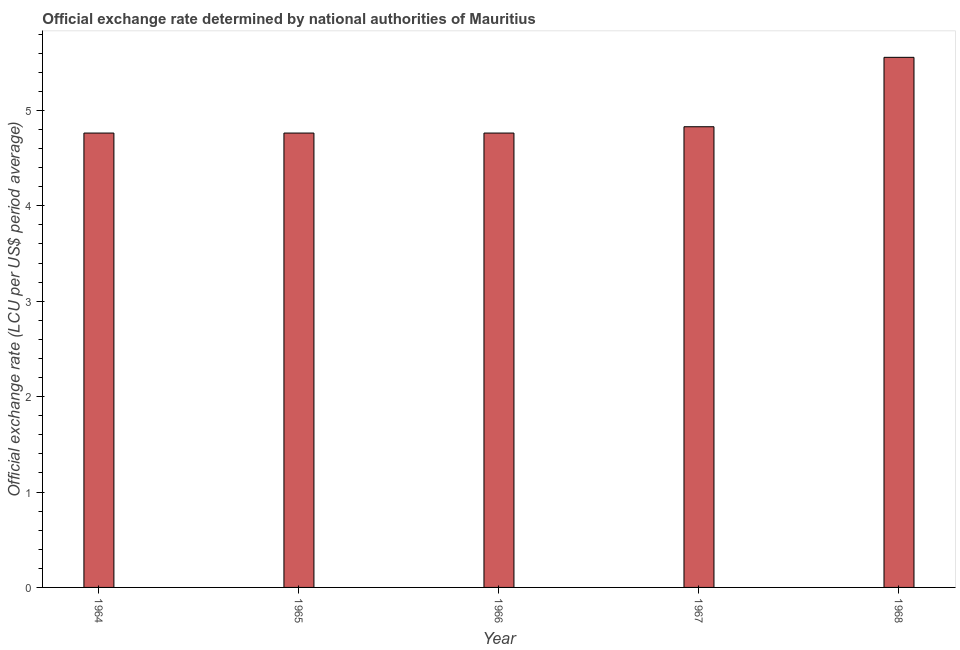What is the title of the graph?
Your answer should be compact. Official exchange rate determined by national authorities of Mauritius. What is the label or title of the X-axis?
Make the answer very short. Year. What is the label or title of the Y-axis?
Your answer should be compact. Official exchange rate (LCU per US$ period average). What is the official exchange rate in 1965?
Provide a succinct answer. 4.76. Across all years, what is the maximum official exchange rate?
Give a very brief answer. 5.56. Across all years, what is the minimum official exchange rate?
Your answer should be compact. 4.76. In which year was the official exchange rate maximum?
Offer a very short reply. 1968. In which year was the official exchange rate minimum?
Your answer should be compact. 1964. What is the sum of the official exchange rate?
Your response must be concise. 24.67. What is the difference between the official exchange rate in 1966 and 1968?
Offer a terse response. -0.79. What is the average official exchange rate per year?
Offer a very short reply. 4.93. What is the median official exchange rate?
Give a very brief answer. 4.76. What is the ratio of the official exchange rate in 1964 to that in 1967?
Your response must be concise. 0.99. What is the difference between the highest and the second highest official exchange rate?
Provide a succinct answer. 0.73. What is the difference between the highest and the lowest official exchange rate?
Provide a succinct answer. 0.79. In how many years, is the official exchange rate greater than the average official exchange rate taken over all years?
Provide a succinct answer. 1. Are the values on the major ticks of Y-axis written in scientific E-notation?
Keep it short and to the point. No. What is the Official exchange rate (LCU per US$ period average) of 1964?
Offer a very short reply. 4.76. What is the Official exchange rate (LCU per US$ period average) in 1965?
Make the answer very short. 4.76. What is the Official exchange rate (LCU per US$ period average) in 1966?
Give a very brief answer. 4.76. What is the Official exchange rate (LCU per US$ period average) of 1967?
Offer a terse response. 4.83. What is the Official exchange rate (LCU per US$ period average) in 1968?
Offer a very short reply. 5.56. What is the difference between the Official exchange rate (LCU per US$ period average) in 1964 and 1966?
Make the answer very short. 0. What is the difference between the Official exchange rate (LCU per US$ period average) in 1964 and 1967?
Your response must be concise. -0.07. What is the difference between the Official exchange rate (LCU per US$ period average) in 1964 and 1968?
Give a very brief answer. -0.79. What is the difference between the Official exchange rate (LCU per US$ period average) in 1965 and 1967?
Provide a short and direct response. -0.07. What is the difference between the Official exchange rate (LCU per US$ period average) in 1965 and 1968?
Your answer should be very brief. -0.79. What is the difference between the Official exchange rate (LCU per US$ period average) in 1966 and 1967?
Keep it short and to the point. -0.07. What is the difference between the Official exchange rate (LCU per US$ period average) in 1966 and 1968?
Your answer should be very brief. -0.79. What is the difference between the Official exchange rate (LCU per US$ period average) in 1967 and 1968?
Offer a very short reply. -0.73. What is the ratio of the Official exchange rate (LCU per US$ period average) in 1964 to that in 1967?
Give a very brief answer. 0.99. What is the ratio of the Official exchange rate (LCU per US$ period average) in 1964 to that in 1968?
Your answer should be very brief. 0.86. What is the ratio of the Official exchange rate (LCU per US$ period average) in 1965 to that in 1967?
Offer a terse response. 0.99. What is the ratio of the Official exchange rate (LCU per US$ period average) in 1965 to that in 1968?
Offer a terse response. 0.86. What is the ratio of the Official exchange rate (LCU per US$ period average) in 1966 to that in 1967?
Make the answer very short. 0.99. What is the ratio of the Official exchange rate (LCU per US$ period average) in 1966 to that in 1968?
Provide a short and direct response. 0.86. What is the ratio of the Official exchange rate (LCU per US$ period average) in 1967 to that in 1968?
Your answer should be very brief. 0.87. 